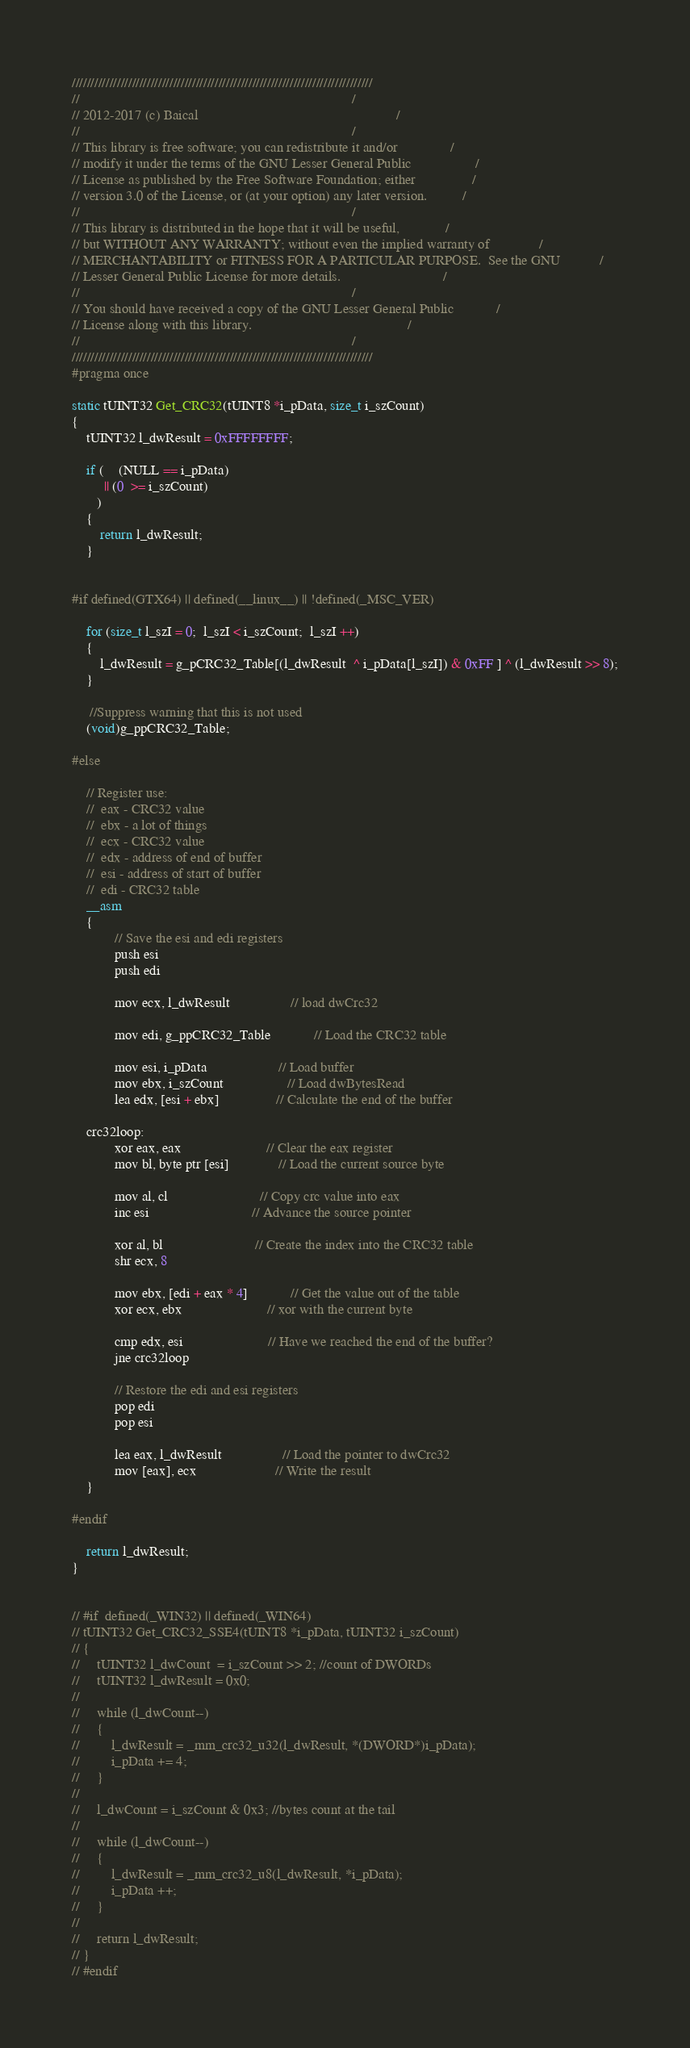Convert code to text. <code><loc_0><loc_0><loc_500><loc_500><_C_>////////////////////////////////////////////////////////////////////////////////
//                                                                             /
// 2012-2017 (c) Baical                                                        /
//                                                                             /
// This library is free software; you can redistribute it and/or               /
// modify it under the terms of the GNU Lesser General Public                  /
// License as published by the Free Software Foundation; either                /
// version 3.0 of the License, or (at your option) any later version.          /
//                                                                             /
// This library is distributed in the hope that it will be useful,             /
// but WITHOUT ANY WARRANTY; without even the implied warranty of              /
// MERCHANTABILITY or FITNESS FOR A PARTICULAR PURPOSE.  See the GNU           /
// Lesser General Public License for more details.                             /
//                                                                             /
// You should have received a copy of the GNU Lesser General Public            /
// License along with this library.                                            /
//                                                                             /
////////////////////////////////////////////////////////////////////////////////
#pragma once

static tUINT32 Get_CRC32(tUINT8 *i_pData, size_t i_szCount)
{
    tUINT32 l_dwResult = 0xFFFFFFFF;

    if (    (NULL == i_pData)
         || (0  >= i_szCount) 
       )
    {
        return l_dwResult;
    }


#if defined(GTX64) || defined(__linux__) || !defined(_MSC_VER)

    for (size_t l_szI = 0;  l_szI < i_szCount;  l_szI ++)
    {
        l_dwResult = g_pCRC32_Table[(l_dwResult  ^ i_pData[l_szI]) & 0xFF ] ^ (l_dwResult >> 8);
    }

     //Suppress warning that this is not used
    (void)g_ppCRC32_Table;

#else

    // Register use:
    //  eax - CRC32 value
    //  ebx - a lot of things
    //  ecx - CRC32 value
    //  edx - address of end of buffer
    //  esi - address of start of buffer
    //  edi - CRC32 table
    __asm
    {
            // Save the esi and edi registers
            push esi
            push edi

            mov ecx, l_dwResult                 // load dwCrc32

            mov edi, g_ppCRC32_Table            // Load the CRC32 table

            mov esi, i_pData                    // Load buffer
            mov ebx, i_szCount                  // Load dwBytesRead
            lea edx, [esi + ebx]                // Calculate the end of the buffer

    crc32loop:
            xor eax, eax                        // Clear the eax register
            mov bl, byte ptr [esi]              // Load the current source byte

            mov al, cl                          // Copy crc value into eax
            inc esi                             // Advance the source pointer

            xor al, bl                          // Create the index into the CRC32 table
            shr ecx, 8

            mov ebx, [edi + eax * 4]            // Get the value out of the table
            xor ecx, ebx                        // xor with the current byte

            cmp edx, esi                        // Have we reached the end of the buffer?
            jne crc32loop

            // Restore the edi and esi registers
            pop edi
            pop esi

            lea eax, l_dwResult                 // Load the pointer to dwCrc32
            mov [eax], ecx                      // Write the result
    }

#endif

    return l_dwResult;
}


// #if  defined(_WIN32) || defined(_WIN64)
// tUINT32 Get_CRC32_SSE4(tUINT8 *i_pData, tUINT32 i_szCount)
// {
//     tUINT32 l_dwCount  = i_szCount >> 2; //count of DWORDs
//     tUINT32 l_dwResult = 0x0;
//     
//     while (l_dwCount--)
//     {
//         l_dwResult = _mm_crc32_u32(l_dwResult, *(DWORD*)i_pData);
//         i_pData += 4;
//     }
// 
//     l_dwCount = i_szCount & 0x3; //bytes count at the tail
// 
//     while (l_dwCount--)
//     {
//         l_dwResult = _mm_crc32_u8(l_dwResult, *i_pData);
//         i_pData ++;
//     }
// 
//     return l_dwResult;
// } 
// #endif 
</code> 